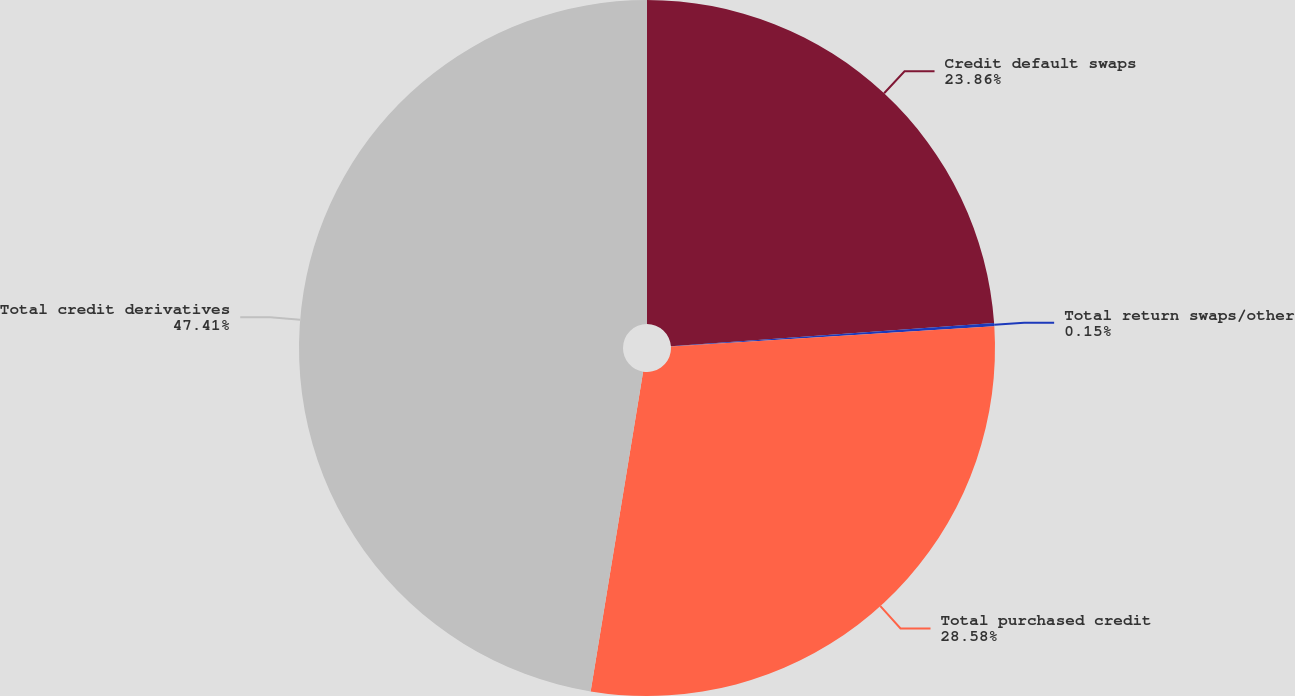Convert chart. <chart><loc_0><loc_0><loc_500><loc_500><pie_chart><fcel>Credit default swaps<fcel>Total return swaps/other<fcel>Total purchased credit<fcel>Total credit derivatives<nl><fcel>23.86%<fcel>0.15%<fcel>28.58%<fcel>47.41%<nl></chart> 